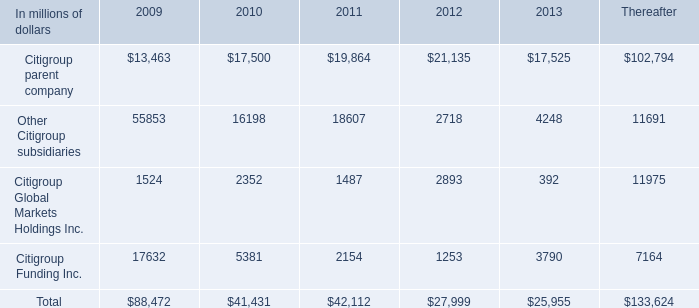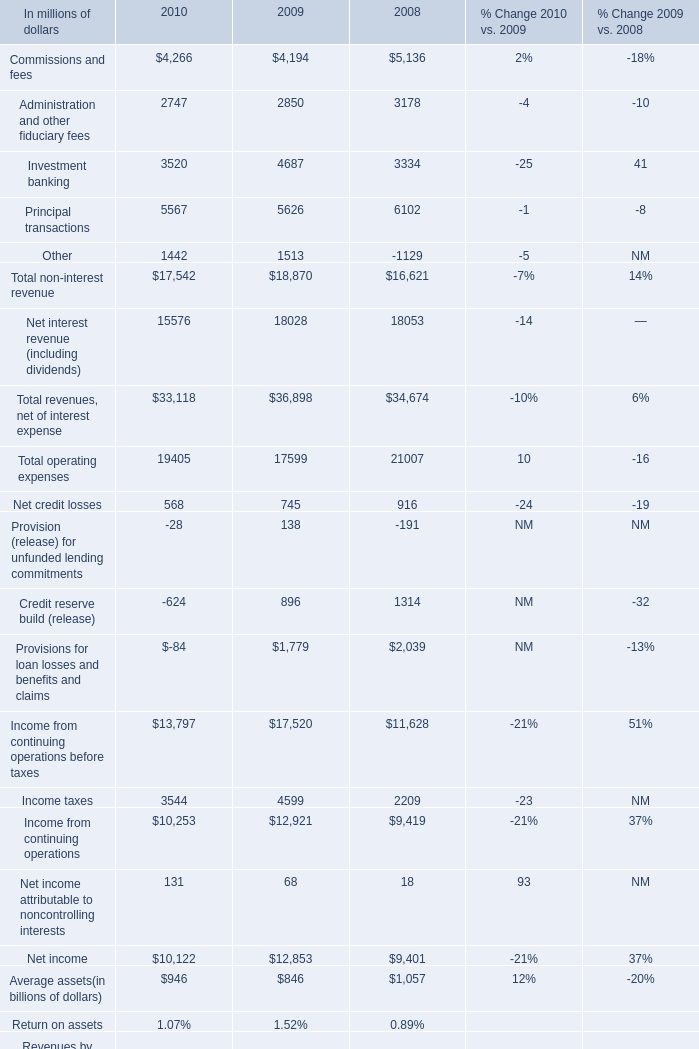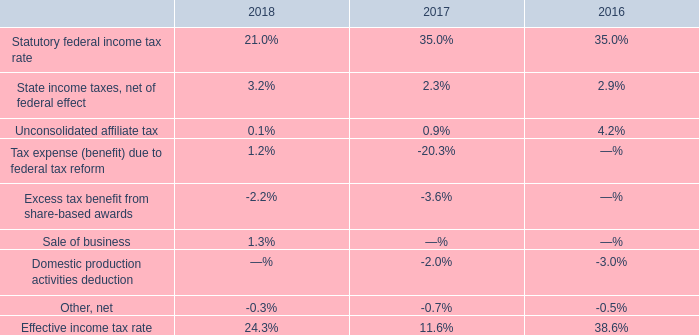what's the total amount of Citigroup parent company of 2013, and Administration and other fiduciary fees of 2008 ? 
Computations: (17525.0 + 3178.0)
Answer: 20703.0. 